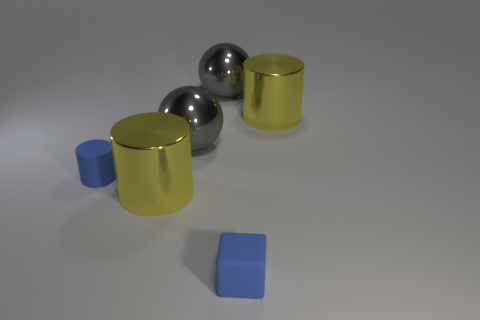Subtract all large metallic cylinders. How many cylinders are left? 1 Subtract all brown blocks. How many yellow cylinders are left? 2 Add 1 tiny purple rubber blocks. How many objects exist? 7 Subtract all balls. How many objects are left? 4 Subtract all large yellow metallic things. Subtract all yellow shiny things. How many objects are left? 2 Add 6 yellow metal objects. How many yellow metal objects are left? 8 Add 6 tiny gray metallic objects. How many tiny gray metallic objects exist? 6 Subtract 0 cyan balls. How many objects are left? 6 